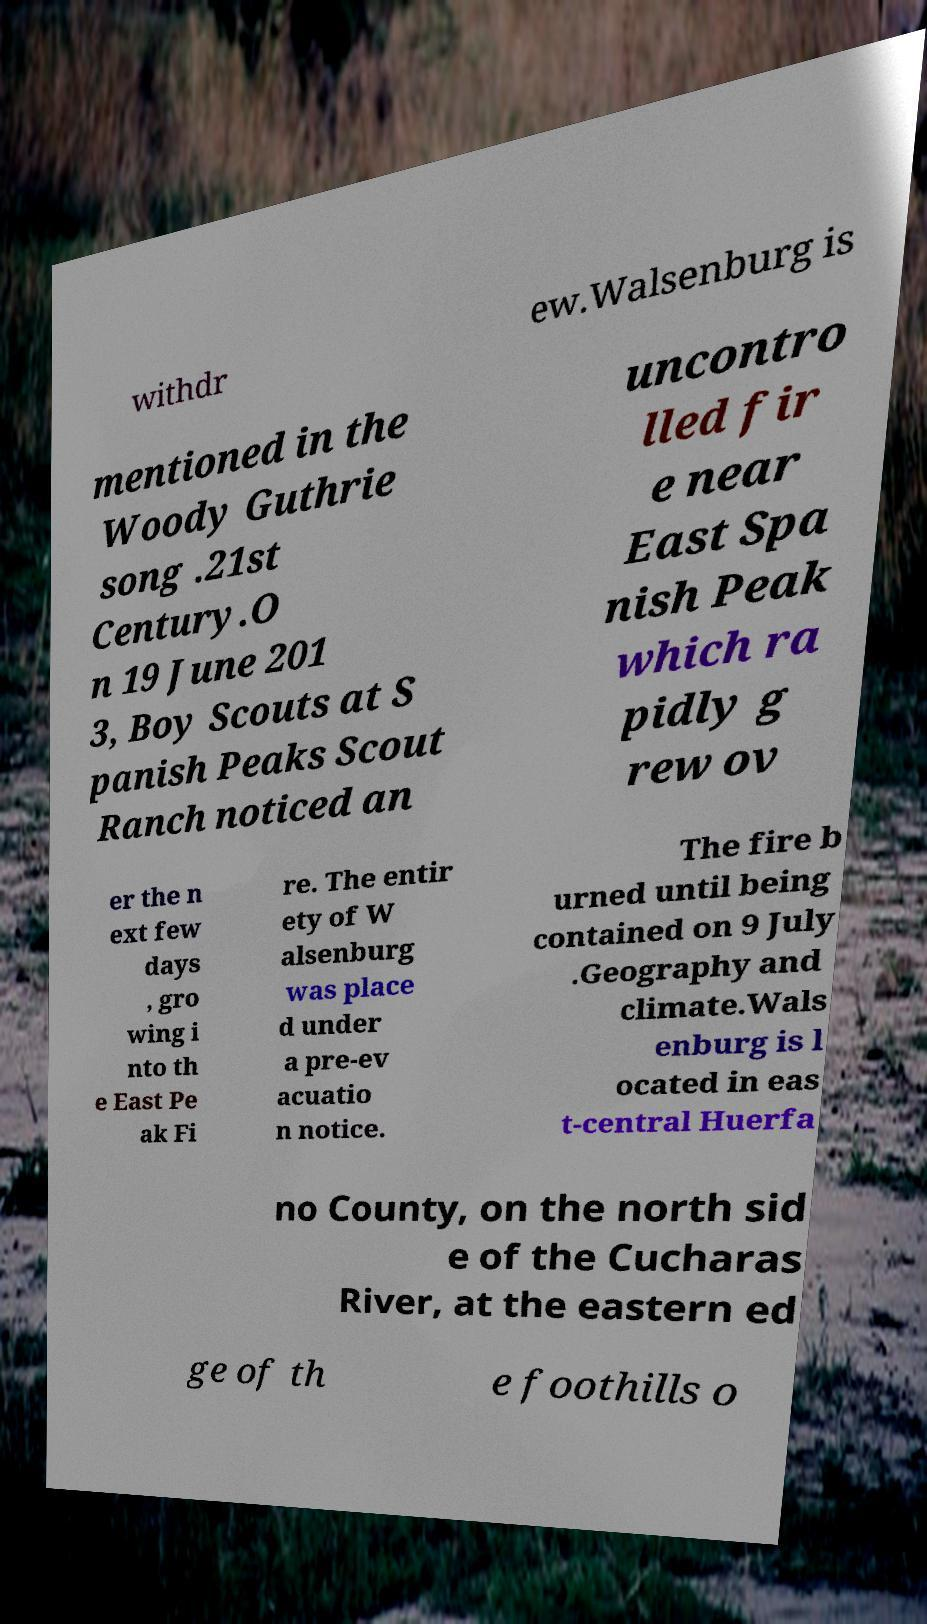Could you extract and type out the text from this image? withdr ew.Walsenburg is mentioned in the Woody Guthrie song .21st Century.O n 19 June 201 3, Boy Scouts at S panish Peaks Scout Ranch noticed an uncontro lled fir e near East Spa nish Peak which ra pidly g rew ov er the n ext few days , gro wing i nto th e East Pe ak Fi re. The entir ety of W alsenburg was place d under a pre-ev acuatio n notice. The fire b urned until being contained on 9 July .Geography and climate.Wals enburg is l ocated in eas t-central Huerfa no County, on the north sid e of the Cucharas River, at the eastern ed ge of th e foothills o 